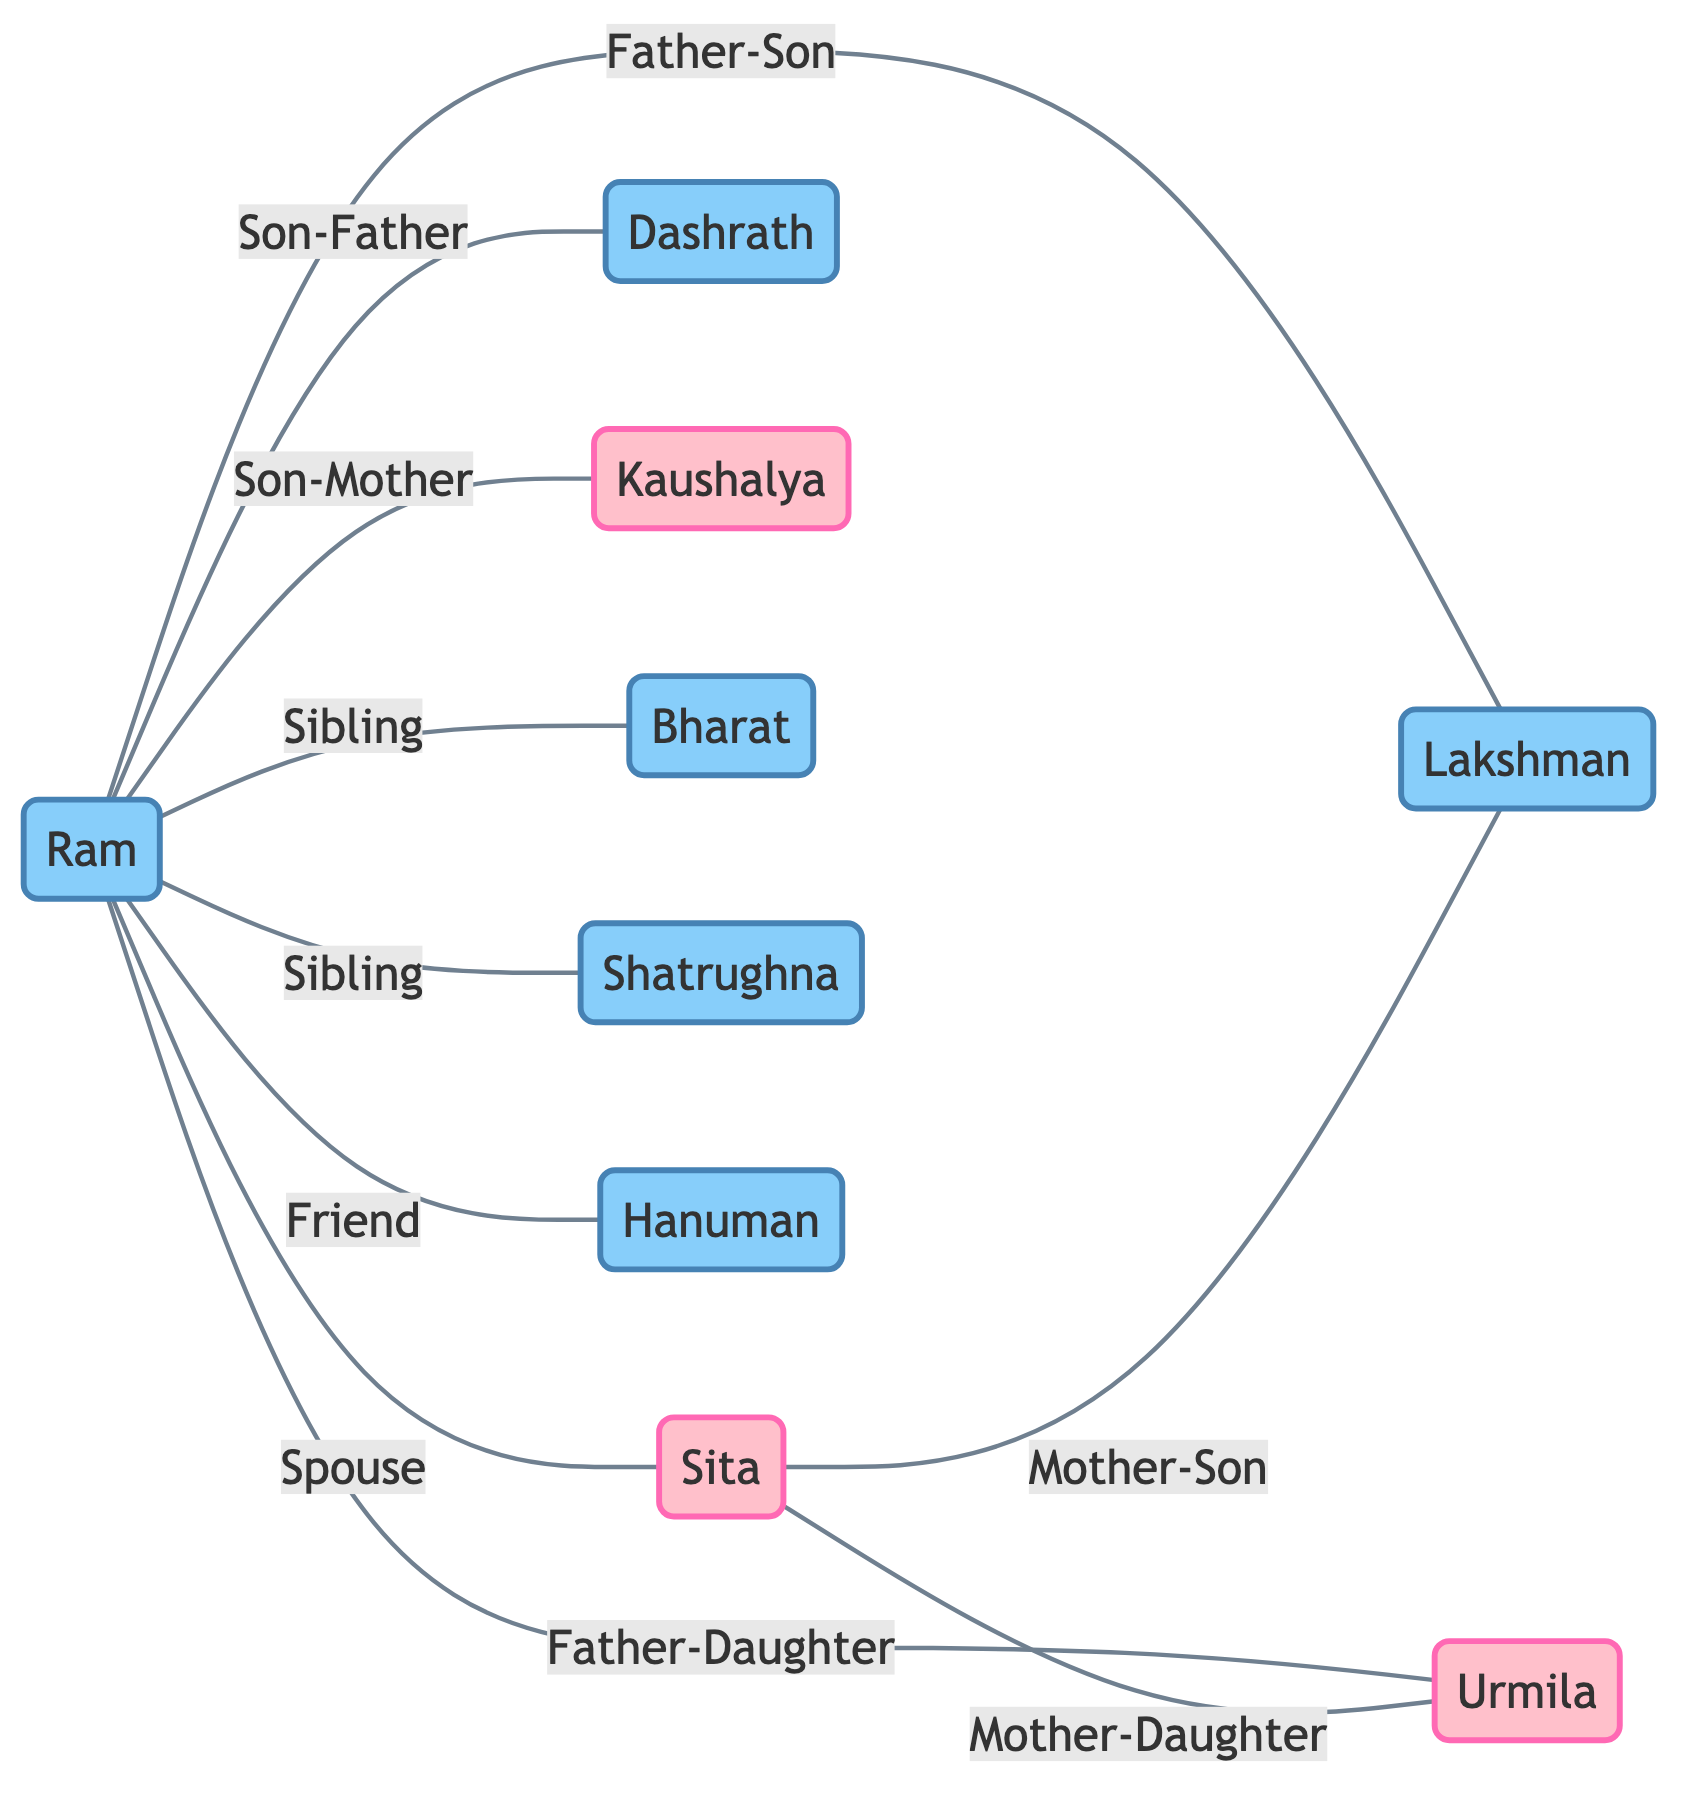What is the relationship between Ram and Sita? The diagram shows a direct connection between Ram and Sita labeled as "Spouse", indicating they are married to each other.
Answer: Spouse How many siblings does Ram have? The diagram displays two connections labeled "Sibling" between Ram and his brothers Bharat and Shatrughna, indicating he has two siblings.
Answer: 2 Who is the mother of Lakshman? The connection labeled "Mother-Son" from Sita to Lakshman indicates Sita is his mother.
Answer: Sita What is the gender of Urmila? Based on the diagram, Urmila is shown as a female node with the label "Female".
Answer: Female How many edges are present in the graph? The edges represent relationships; counting all unique connections, there are a total of 9 edges shown in the diagram.
Answer: 9 Who is Ram's close friend? The connection labeled "Friend" from Ram to Hanuman indicates that Hanuman is identified as Ram's close friend.
Answer: Hanuman How is Bharat related to Ram? The diagram shows a connection labeled "Sibling" between Ram and Bharat, indicating they are brothers.
Answer: Brother Which parent of Ram is identified as Kaushalya? The direct relationship "Son-Mother" from Ram to Kaushalya indicates that Kaushalya is Ram's mother.
Answer: Mother What type of graph is this? The diagram represents an Undirected Graph where nodes represent people and edges represent their relationships without a specific direction.
Answer: Undirected Graph 